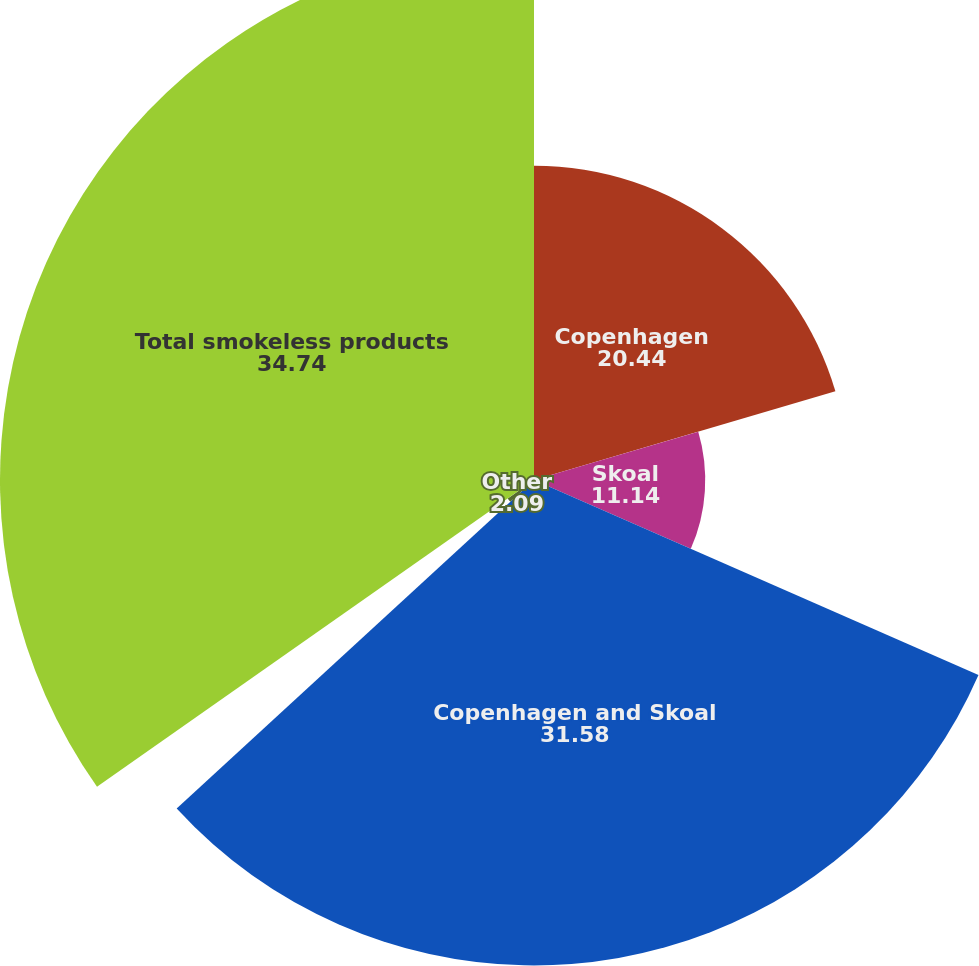Convert chart. <chart><loc_0><loc_0><loc_500><loc_500><pie_chart><fcel>Copenhagen<fcel>Skoal<fcel>Copenhagen and Skoal<fcel>Other<fcel>Total smokeless products<nl><fcel>20.44%<fcel>11.14%<fcel>31.58%<fcel>2.09%<fcel>34.74%<nl></chart> 